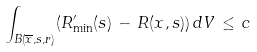<formula> <loc_0><loc_0><loc_500><loc_500>\int _ { B ( \overline { x } , { s } , r ) } ( R ^ { \prime } _ { \min } ( { s } ) \, - \, R ( x , { s } ) ) \, d V \, \leq \, c</formula> 